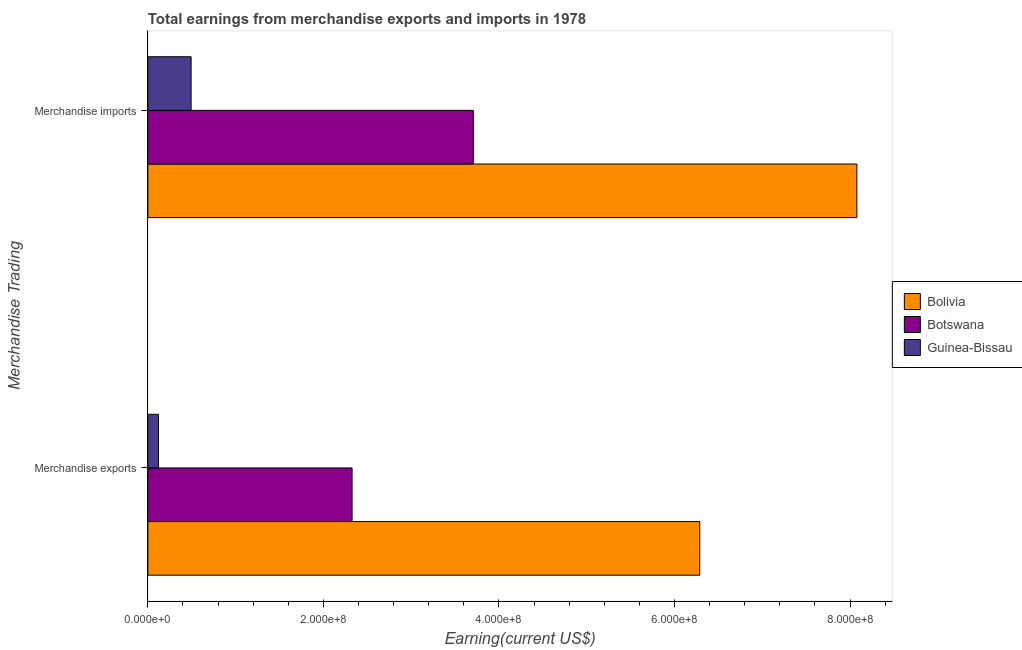How many groups of bars are there?
Your response must be concise. 2. Are the number of bars per tick equal to the number of legend labels?
Your answer should be compact. Yes. How many bars are there on the 1st tick from the top?
Offer a terse response. 3. How many bars are there on the 2nd tick from the bottom?
Your response must be concise. 3. What is the label of the 1st group of bars from the top?
Your answer should be very brief. Merchandise imports. What is the earnings from merchandise imports in Bolivia?
Provide a short and direct response. 8.08e+08. Across all countries, what is the maximum earnings from merchandise exports?
Offer a terse response. 6.29e+08. Across all countries, what is the minimum earnings from merchandise exports?
Ensure brevity in your answer.  1.21e+07. In which country was the earnings from merchandise exports maximum?
Offer a very short reply. Bolivia. In which country was the earnings from merchandise imports minimum?
Your response must be concise. Guinea-Bissau. What is the total earnings from merchandise imports in the graph?
Provide a succinct answer. 1.23e+09. What is the difference between the earnings from merchandise imports in Botswana and that in Bolivia?
Provide a short and direct response. -4.37e+08. What is the difference between the earnings from merchandise exports in Bolivia and the earnings from merchandise imports in Botswana?
Ensure brevity in your answer.  2.58e+08. What is the average earnings from merchandise imports per country?
Your answer should be compact. 4.09e+08. What is the difference between the earnings from merchandise imports and earnings from merchandise exports in Botswana?
Make the answer very short. 1.38e+08. In how many countries, is the earnings from merchandise imports greater than 480000000 US$?
Provide a short and direct response. 1. What is the ratio of the earnings from merchandise exports in Bolivia to that in Guinea-Bissau?
Give a very brief answer. 52.13. What is the difference between two consecutive major ticks on the X-axis?
Ensure brevity in your answer.  2.00e+08. Are the values on the major ticks of X-axis written in scientific E-notation?
Your response must be concise. Yes. Does the graph contain any zero values?
Give a very brief answer. No. Does the graph contain grids?
Ensure brevity in your answer.  No. How are the legend labels stacked?
Your answer should be very brief. Vertical. What is the title of the graph?
Your response must be concise. Total earnings from merchandise exports and imports in 1978. Does "Marshall Islands" appear as one of the legend labels in the graph?
Keep it short and to the point. No. What is the label or title of the X-axis?
Offer a terse response. Earning(current US$). What is the label or title of the Y-axis?
Keep it short and to the point. Merchandise Trading. What is the Earning(current US$) in Bolivia in Merchandise exports?
Your response must be concise. 6.29e+08. What is the Earning(current US$) in Botswana in Merchandise exports?
Provide a short and direct response. 2.33e+08. What is the Earning(current US$) in Guinea-Bissau in Merchandise exports?
Make the answer very short. 1.21e+07. What is the Earning(current US$) in Bolivia in Merchandise imports?
Ensure brevity in your answer.  8.08e+08. What is the Earning(current US$) of Botswana in Merchandise imports?
Offer a very short reply. 3.71e+08. What is the Earning(current US$) of Guinea-Bissau in Merchandise imports?
Offer a terse response. 4.93e+07. Across all Merchandise Trading, what is the maximum Earning(current US$) of Bolivia?
Provide a short and direct response. 8.08e+08. Across all Merchandise Trading, what is the maximum Earning(current US$) in Botswana?
Your response must be concise. 3.71e+08. Across all Merchandise Trading, what is the maximum Earning(current US$) of Guinea-Bissau?
Provide a short and direct response. 4.93e+07. Across all Merchandise Trading, what is the minimum Earning(current US$) in Bolivia?
Give a very brief answer. 6.29e+08. Across all Merchandise Trading, what is the minimum Earning(current US$) in Botswana?
Ensure brevity in your answer.  2.33e+08. Across all Merchandise Trading, what is the minimum Earning(current US$) of Guinea-Bissau?
Give a very brief answer. 1.21e+07. What is the total Earning(current US$) in Bolivia in the graph?
Provide a succinct answer. 1.44e+09. What is the total Earning(current US$) of Botswana in the graph?
Give a very brief answer. 6.03e+08. What is the total Earning(current US$) in Guinea-Bissau in the graph?
Make the answer very short. 6.13e+07. What is the difference between the Earning(current US$) of Bolivia in Merchandise exports and that in Merchandise imports?
Give a very brief answer. -1.79e+08. What is the difference between the Earning(current US$) of Botswana in Merchandise exports and that in Merchandise imports?
Ensure brevity in your answer.  -1.38e+08. What is the difference between the Earning(current US$) of Guinea-Bissau in Merchandise exports and that in Merchandise imports?
Offer a very short reply. -3.72e+07. What is the difference between the Earning(current US$) of Bolivia in Merchandise exports and the Earning(current US$) of Botswana in Merchandise imports?
Make the answer very short. 2.58e+08. What is the difference between the Earning(current US$) in Bolivia in Merchandise exports and the Earning(current US$) in Guinea-Bissau in Merchandise imports?
Your answer should be compact. 5.80e+08. What is the difference between the Earning(current US$) of Botswana in Merchandise exports and the Earning(current US$) of Guinea-Bissau in Merchandise imports?
Give a very brief answer. 1.83e+08. What is the average Earning(current US$) of Bolivia per Merchandise Trading?
Offer a terse response. 7.18e+08. What is the average Earning(current US$) in Botswana per Merchandise Trading?
Give a very brief answer. 3.02e+08. What is the average Earning(current US$) in Guinea-Bissau per Merchandise Trading?
Your answer should be very brief. 3.07e+07. What is the difference between the Earning(current US$) in Bolivia and Earning(current US$) in Botswana in Merchandise exports?
Ensure brevity in your answer.  3.96e+08. What is the difference between the Earning(current US$) in Bolivia and Earning(current US$) in Guinea-Bissau in Merchandise exports?
Give a very brief answer. 6.17e+08. What is the difference between the Earning(current US$) of Botswana and Earning(current US$) of Guinea-Bissau in Merchandise exports?
Your answer should be compact. 2.21e+08. What is the difference between the Earning(current US$) of Bolivia and Earning(current US$) of Botswana in Merchandise imports?
Provide a short and direct response. 4.37e+08. What is the difference between the Earning(current US$) of Bolivia and Earning(current US$) of Guinea-Bissau in Merchandise imports?
Your response must be concise. 7.59e+08. What is the difference between the Earning(current US$) in Botswana and Earning(current US$) in Guinea-Bissau in Merchandise imports?
Your answer should be very brief. 3.22e+08. What is the ratio of the Earning(current US$) of Bolivia in Merchandise exports to that in Merchandise imports?
Make the answer very short. 0.78. What is the ratio of the Earning(current US$) in Botswana in Merchandise exports to that in Merchandise imports?
Give a very brief answer. 0.63. What is the ratio of the Earning(current US$) in Guinea-Bissau in Merchandise exports to that in Merchandise imports?
Your answer should be very brief. 0.24. What is the difference between the highest and the second highest Earning(current US$) of Bolivia?
Make the answer very short. 1.79e+08. What is the difference between the highest and the second highest Earning(current US$) in Botswana?
Provide a succinct answer. 1.38e+08. What is the difference between the highest and the second highest Earning(current US$) of Guinea-Bissau?
Keep it short and to the point. 3.72e+07. What is the difference between the highest and the lowest Earning(current US$) of Bolivia?
Your response must be concise. 1.79e+08. What is the difference between the highest and the lowest Earning(current US$) in Botswana?
Offer a terse response. 1.38e+08. What is the difference between the highest and the lowest Earning(current US$) of Guinea-Bissau?
Provide a succinct answer. 3.72e+07. 